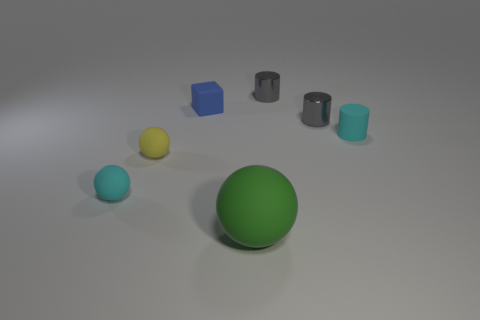Is there anything else that has the same size as the green matte thing?
Make the answer very short. No. There is a thing that is both in front of the small cyan cylinder and behind the tiny cyan sphere; what color is it?
Provide a succinct answer. Yellow. What number of spheres are small blue shiny things or yellow objects?
Provide a short and direct response. 1. Is the shape of the tiny yellow thing the same as the cyan object on the left side of the green matte object?
Provide a succinct answer. Yes. There is a matte thing that is both in front of the small yellow ball and to the right of the tiny blue thing; how big is it?
Your answer should be compact. Large. What is the shape of the big object?
Your response must be concise. Sphere. Is there a small rubber object behind the small cyan object that is on the left side of the rubber cylinder?
Ensure brevity in your answer.  Yes. There is a rubber thing to the right of the green thing; what number of things are in front of it?
Your response must be concise. 3. What material is the cyan ball that is the same size as the matte cube?
Provide a short and direct response. Rubber. Does the tiny cyan rubber object that is left of the big green object have the same shape as the small yellow thing?
Offer a very short reply. Yes. 